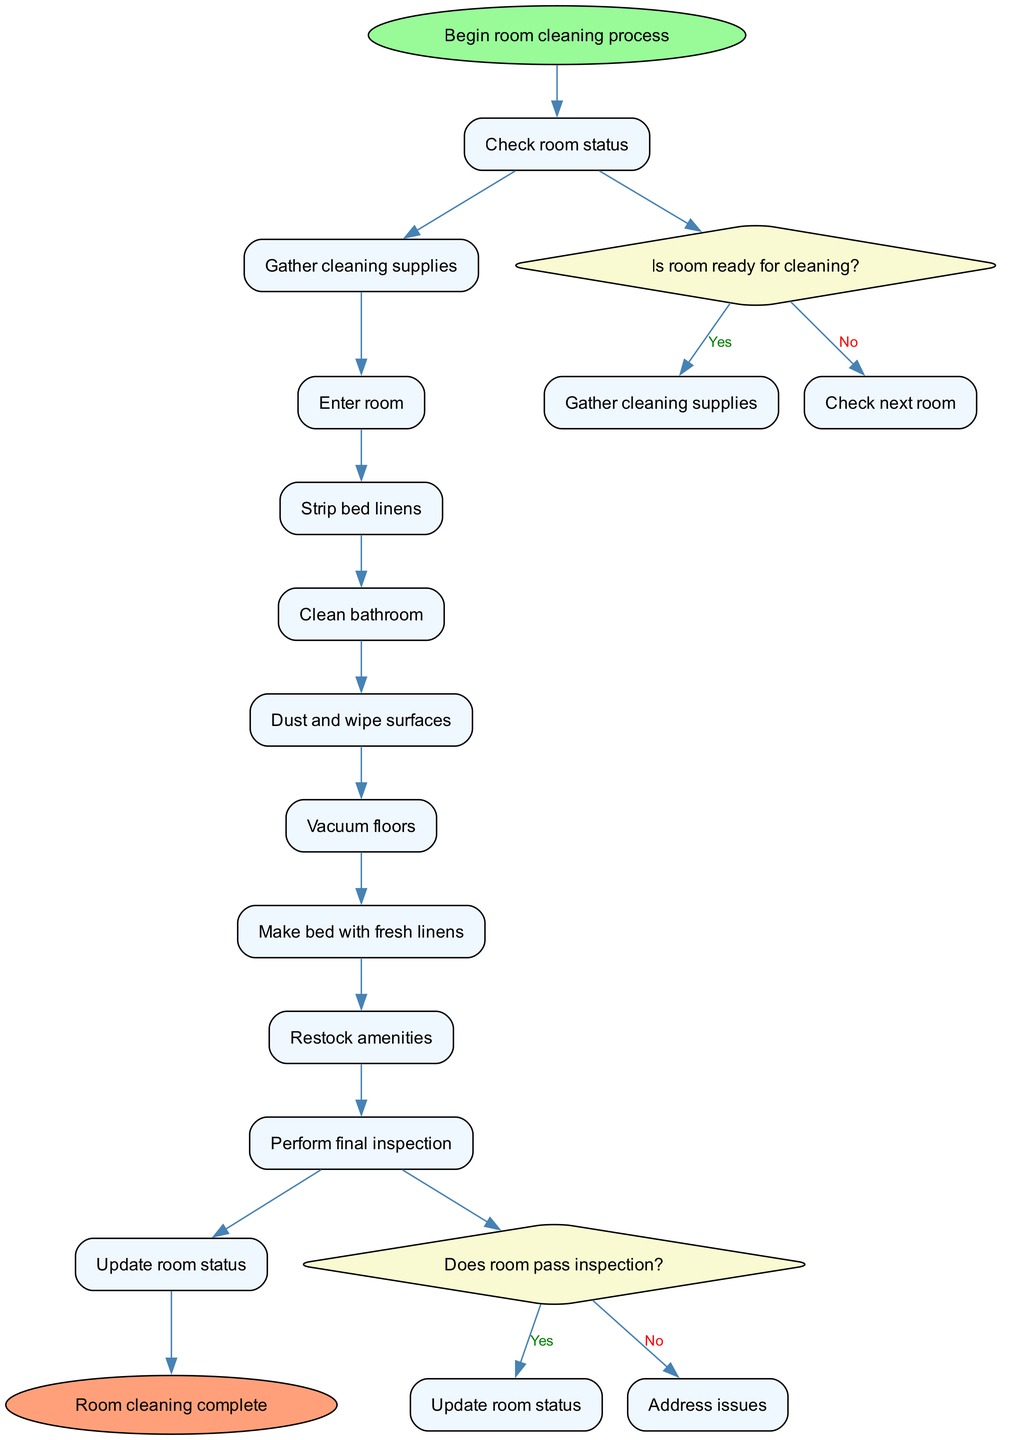What is the first step in the room cleaning process? The first step in the workflow is indicated by the start node, which states "Begin room cleaning process." Therefore, the very first action taken in the process is "Begin room cleaning process."
Answer: Begin room cleaning process How many nodes are present in the diagram? The nodes include all distinct actions and decision points throughout the cleaning process. Counting the provided nodes, there are 10 actions plus 2 decisions, totaling 12 nodes.
Answer: 12 What is the outcome if the room is not ready for cleaning? According to the diagram's decision point regarding room readiness, if the room is not ready for cleaning, the next action is to "Check next room." Thus, the outcome indicates that the current cleaning cannot proceed.
Answer: Check next room Which action follows "Clean bathroom"? The action that directly follows "Clean bathroom" can be determined by examining the nodes in sequence. The next action after cleaning the bathroom is "Dust and wipe surfaces."
Answer: Dust and wipe surfaces What do you do if the room does not pass inspection? In the flowchart, there is a decision point regarding room inspection status. If the room does not pass inspection, the specified action is to "Address issues." Thus, this is the prescribed next step.
Answer: Address issues How many decision points are in the diagram? The decision points are represented as diamonds in the flowchart. The provided data specifies two decision conditions: one for checking room readiness and another for inspection status. Therefore, there are 2 decision points in total.
Answer: 2 What is the last step in the cleaning process? The last step of the cleaning process is indicated by the end node of the workflow, which states, "Room cleaning complete." This signifies that all preceding actions were successfully concluded.
Answer: Room cleaning complete What step comes after making the bed with fresh linens? By analyzing the sequence of nodes after "Make bed with fresh linens," the subsequent action prescribed in the flowchart is to "Restock amenities." Thus, this is the next step.
Answer: Restock amenities What indicates that the room is ready for cleaning? The diagram indicates that before any cleaning supplies are gathered, a check must confirm, "Is room ready for cleaning?" This determination is the critical condition that must be satisfied for the cleaning process to commence.
Answer: Is room ready for cleaning? 